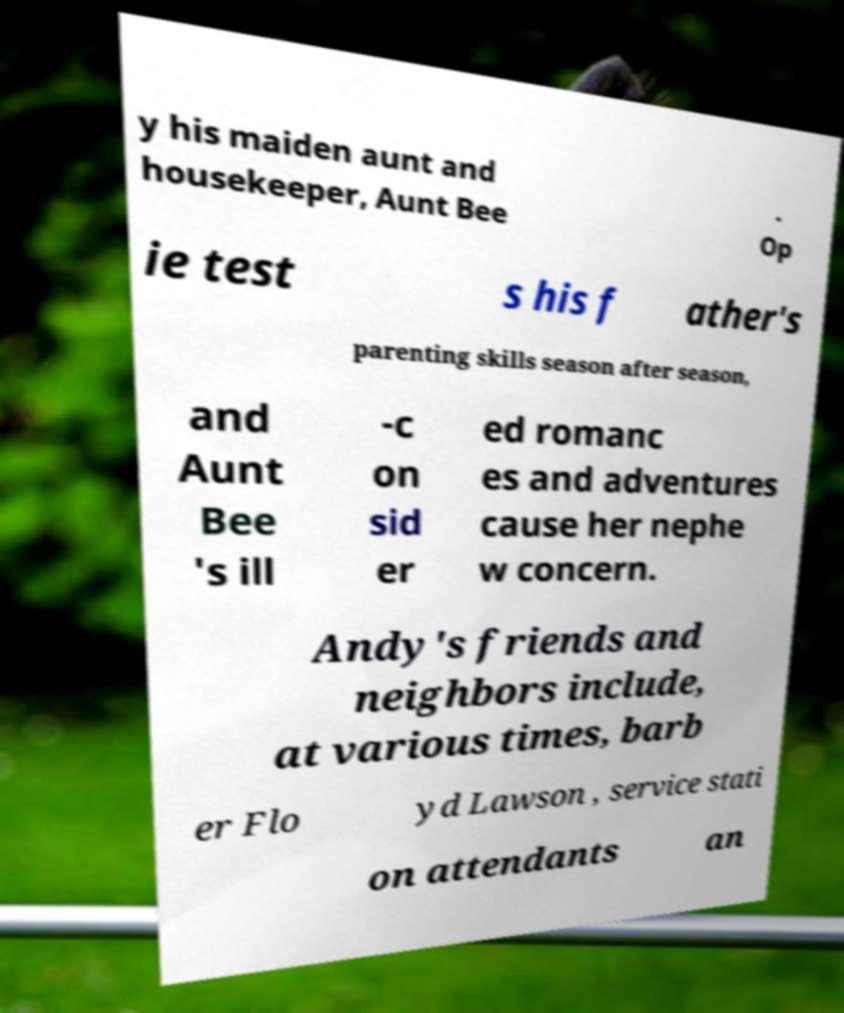There's text embedded in this image that I need extracted. Can you transcribe it verbatim? y his maiden aunt and housekeeper, Aunt Bee . Op ie test s his f ather's parenting skills season after season, and Aunt Bee 's ill -c on sid er ed romanc es and adventures cause her nephe w concern. Andy's friends and neighbors include, at various times, barb er Flo yd Lawson , service stati on attendants an 